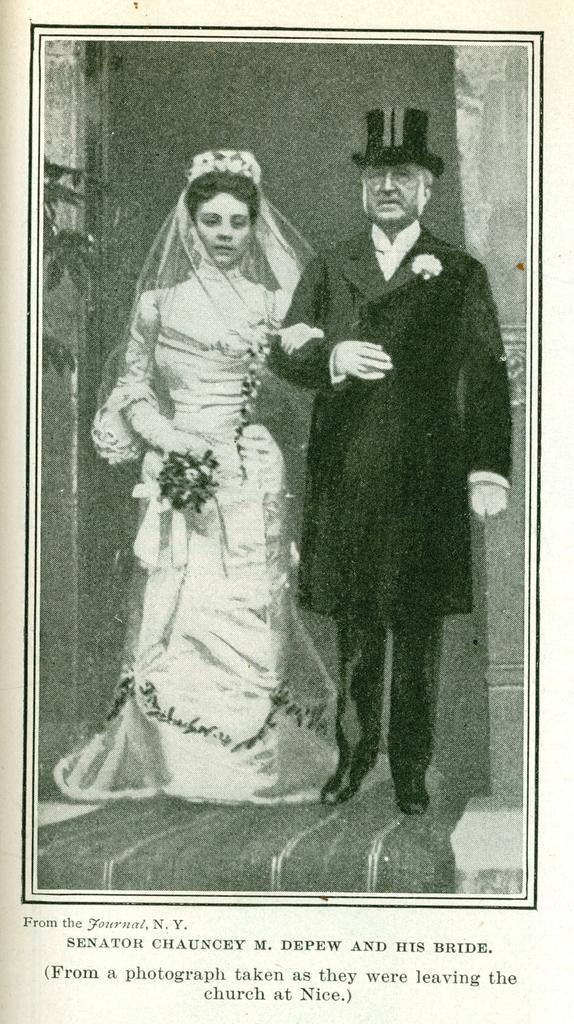What is present on the poster in the image? There is a poster in the image. What type of images are featured on the poster? The poster contains images of a man and a woman. Is there any text present on the poster? Yes, there is text on the poster. How many girls are depicted on the poster? There is no reference to any girls on the poster; it contains images of a man and a woman. What type of comfort can be seen provided by the bell in the image? There is no bell present in the image. 